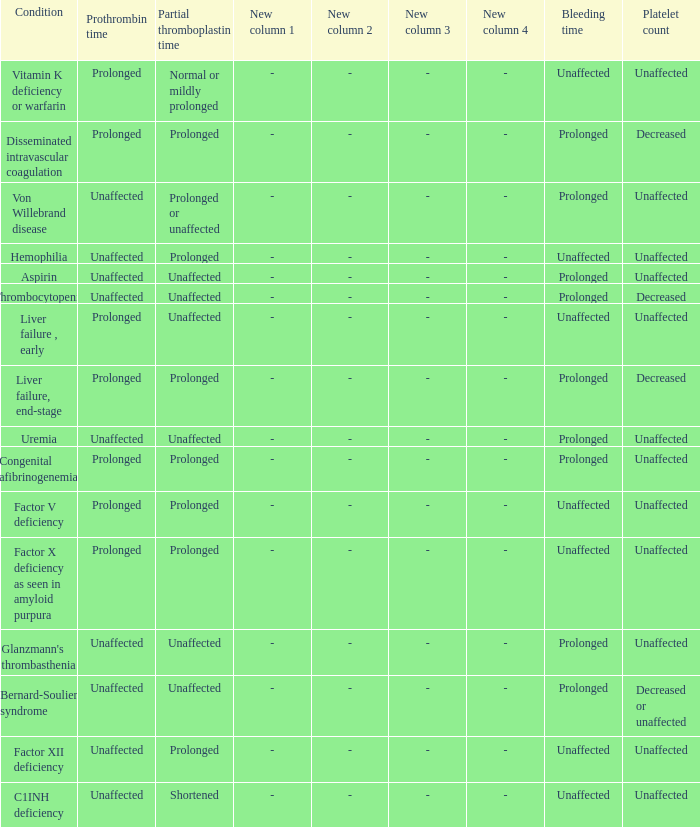Which Condition has an unaffected Prothrombin time and a Bleeding time, and a Partial thromboplastin time of prolonged? Hemophilia, Factor XII deficiency. 